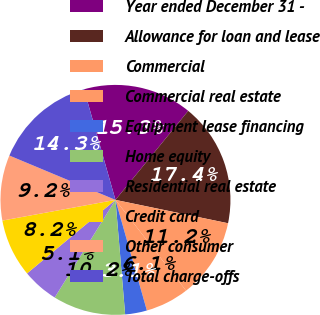Convert chart. <chart><loc_0><loc_0><loc_500><loc_500><pie_chart><fcel>Year ended December 31 -<fcel>Allowance for loan and lease<fcel>Commercial<fcel>Commercial real estate<fcel>Equipment lease financing<fcel>Home equity<fcel>Residential real estate<fcel>Credit card<fcel>Other consumer<fcel>Total charge-offs<nl><fcel>15.31%<fcel>17.35%<fcel>11.22%<fcel>6.12%<fcel>3.06%<fcel>10.2%<fcel>5.1%<fcel>8.16%<fcel>9.18%<fcel>14.29%<nl></chart> 